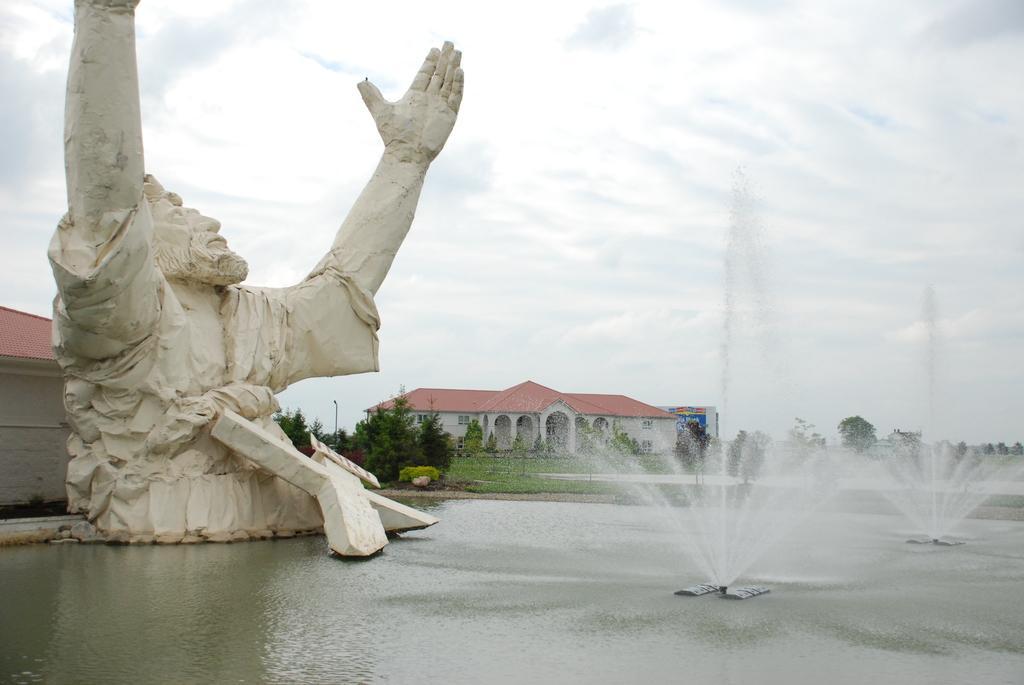Could you give a brief overview of what you see in this image? In the image there is a sculpture and there is a water surface and two fountains on the water surface in front of the sculpture and in the background there is a house and in front of the house there are many trees. 